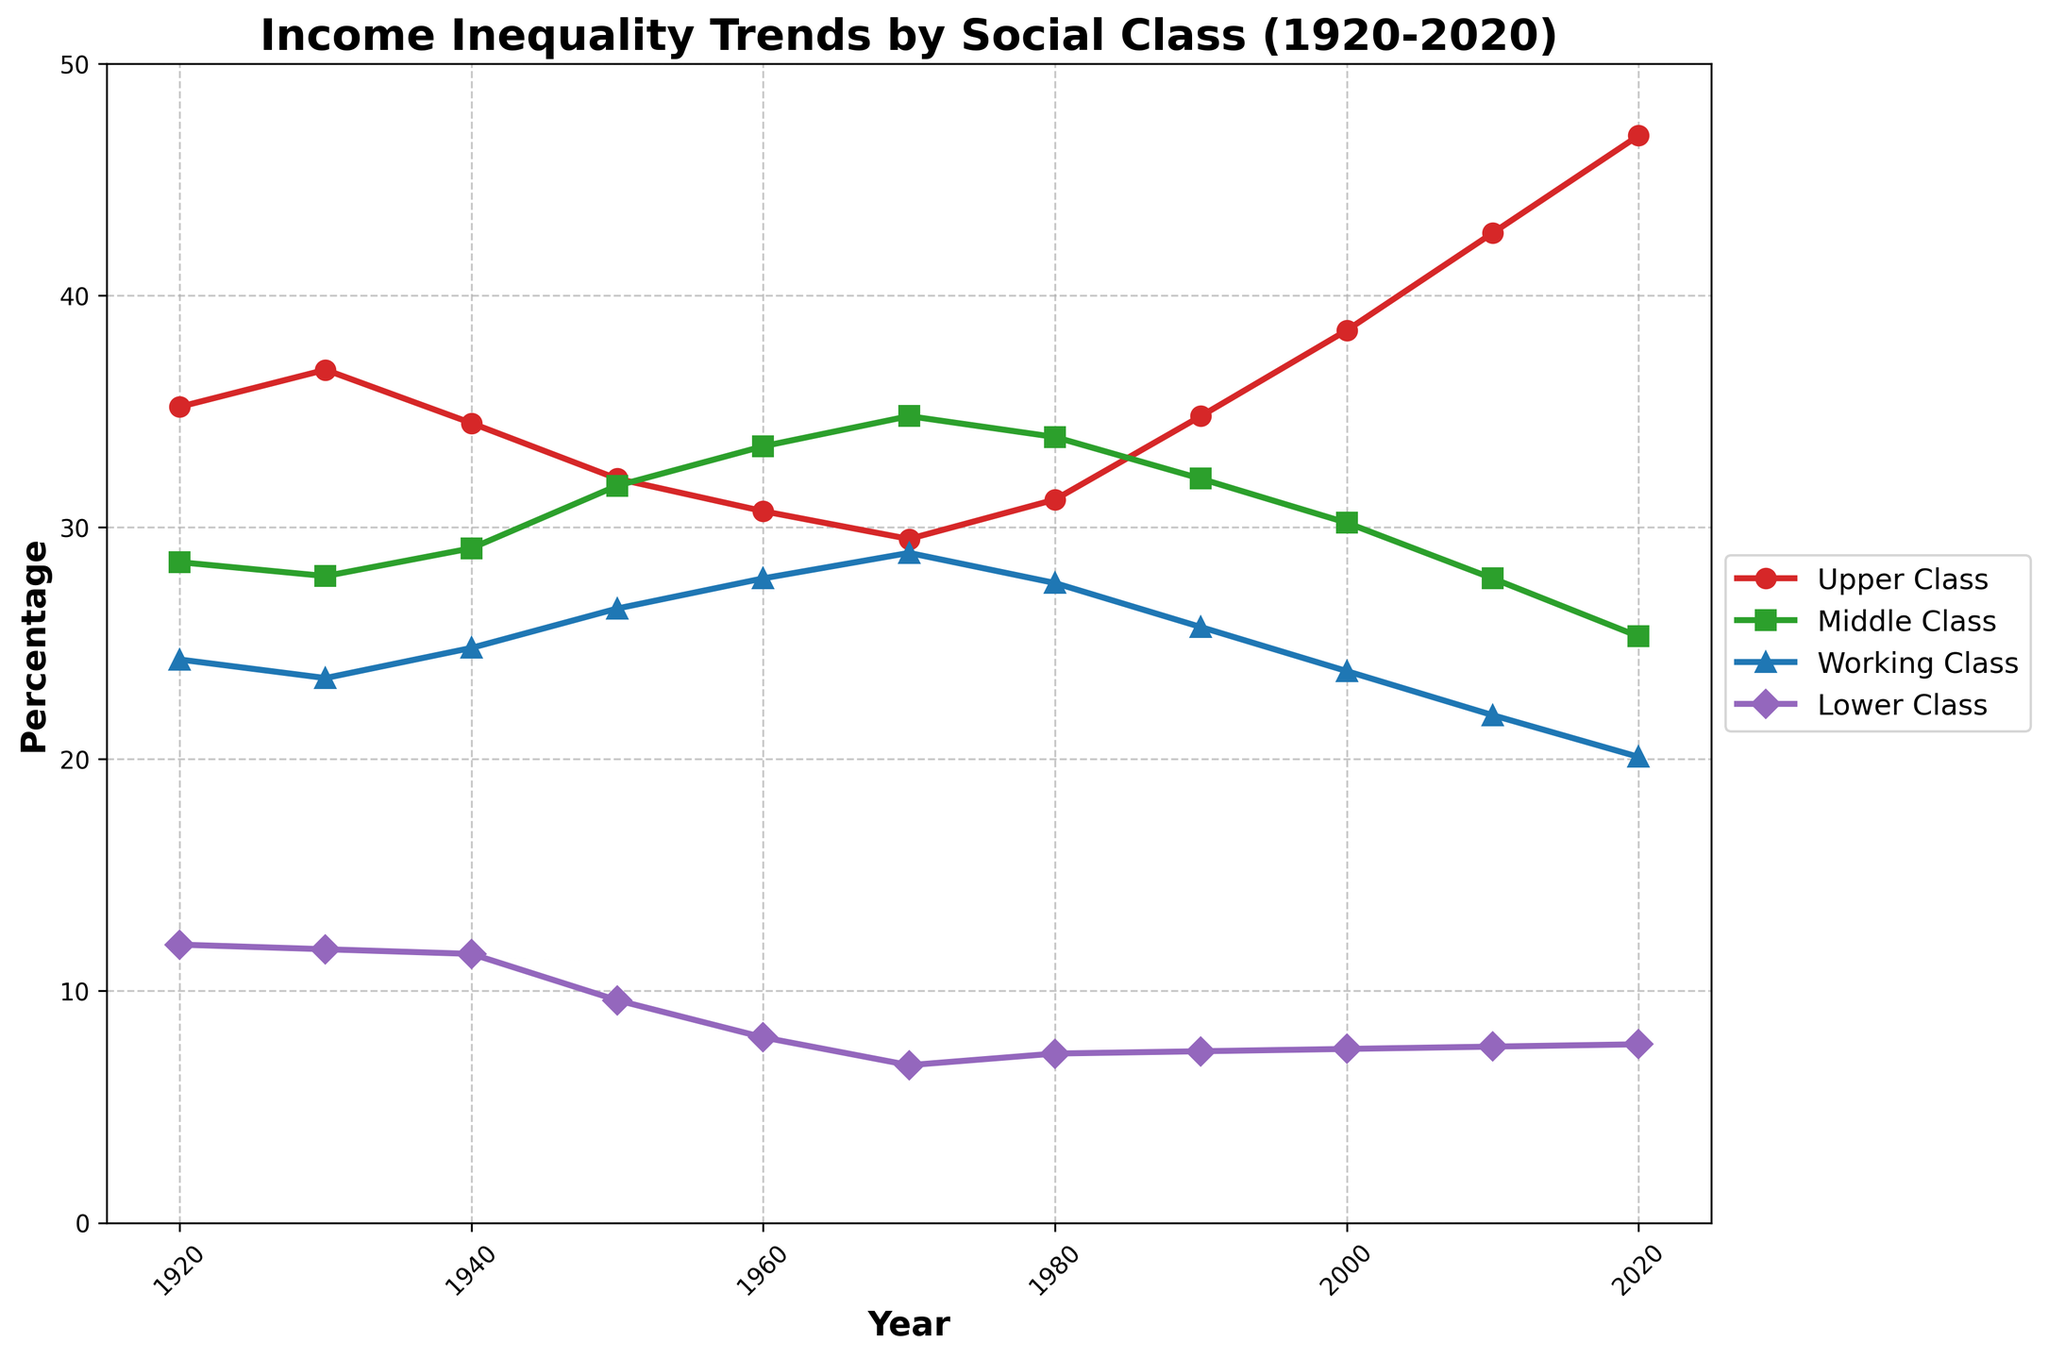What is the general trend of income percentage for the Upper Class from 1920 to 2020? The line representing the Upper Class income percentage shows a steady increase from 35.2% in 1920 to 46.9% in 2020. This indicates a growing share of income for the Upper Class over the century.
Answer: Increasing Which social class had the highest income percentage in the year 1960? By observing the data points and the lines in the figure, the Middle Class had the highest income percentage in 1960 at 33.5%.
Answer: Middle Class How does the income percentage of the Working Class in 1950 compare to that in 2020? The Working Class income percentage in 1950 is 26.5% and in 2020 it is 20.1%. By comparing these two values, we see a decrease in the income percentage for the Working Class.
Answer: Decreased What is the difference in the income percentage of the Lower Class between 1920 and 2020? The income percentage for the Lower Class in 1920 was 12.0% and in 2020 it was 7.7%. The difference can be found by subtracting 7.7 from 12.0, which equals 4.3%.
Answer: 4.3% In which decade did the Upper Class experience the most significant increase in their income percentage? By examining the slopes of the Upper Class line, the most significant increase occurred between 2000 and 2010, where the income percentage rose from 38.5% to 42.7%, a 4.2% increase.
Answer: 2000-2010 Which class had the smallest percentage of income in 1970, and what was the value? The Lower Class had the smallest percentage of income in 1970, with a value of 6.8%. This can be identified by looking at the lowest point on the y-axis for that year.
Answer: Lower Class, 6.8% Compare the income percentage of the Middle Class in 1930 and 1940. Which year had a higher value and by how much? The income percentage for the Middle Class in 1930 was 27.9%, and in 1940 it was 29.1%. The value was higher in 1940 by 1.2%.
Answer: 1940 by 1.2% From 1990 to 2000, which social class saw the most decline in income percentage and by what amount? Analyzing the data points, the Middle Class saw a decline from 32.1% in 1990 to 30.2% in 2000, a decrease of 1.9%.
Answer: Middle Class, 1.9% What is the average income percentage for the Upper Class from 1920 to 2020? Sum the income percentages of Upper Class from 1920 to 2020 (35.2 + 36.8 + 34.5 + 32.1 + 30.7 + 29.5 + 31.2 + 34.8 + 38.5 + 42.7 + 46.9) and divide by the number of years (11): (393.9 / 11) = 35.81%.
Answer: 35.81% 